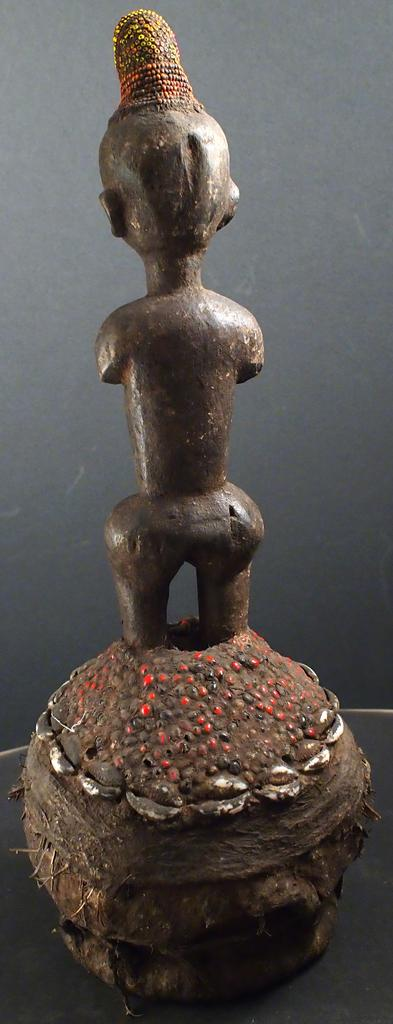What is the main subject in the image? There is a statue in the image. Where is the statue located? The statue is on a surface. What type of smoke is coming out of the statue's head in the image? There is no smoke coming out of the statue's head in the image; it is a solid structure. 